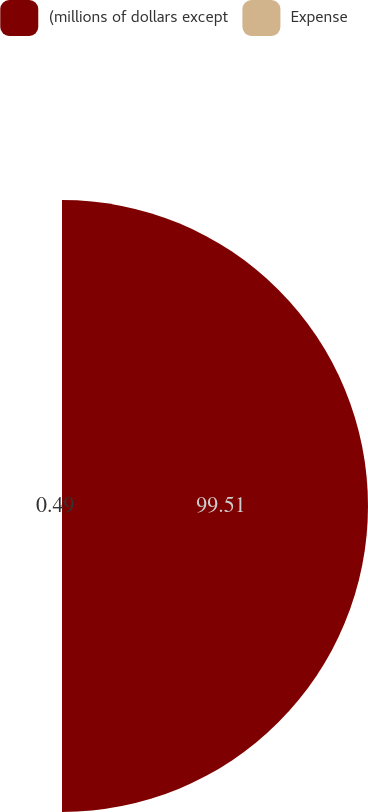Convert chart. <chart><loc_0><loc_0><loc_500><loc_500><pie_chart><fcel>(millions of dollars except<fcel>Expense<nl><fcel>99.51%<fcel>0.49%<nl></chart> 